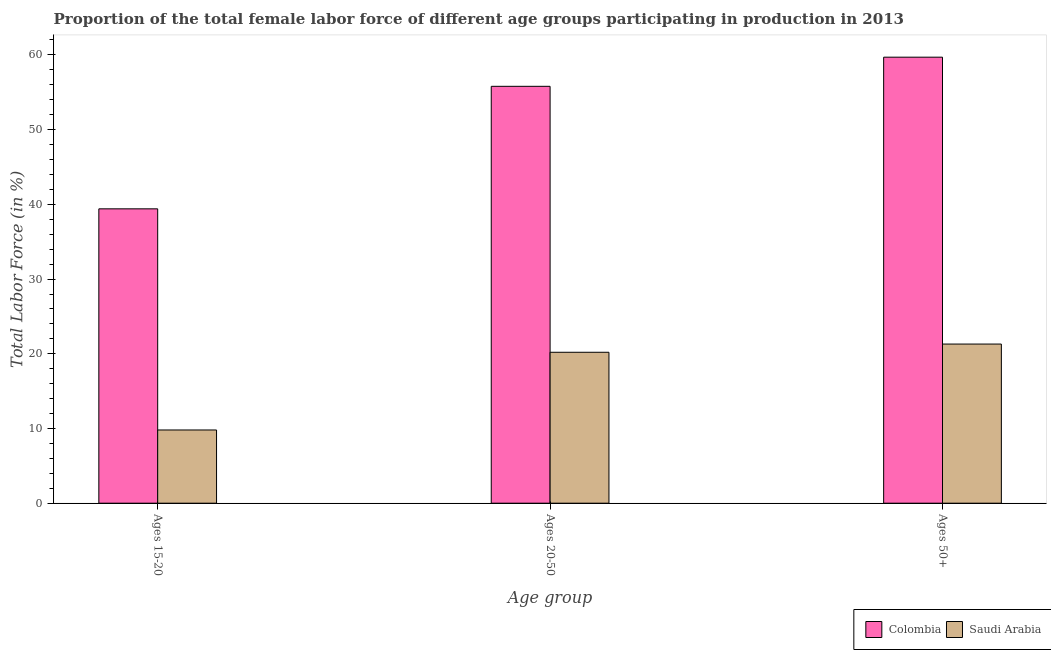How many different coloured bars are there?
Make the answer very short. 2. What is the label of the 3rd group of bars from the left?
Your answer should be very brief. Ages 50+. What is the percentage of female labor force within the age group 20-50 in Saudi Arabia?
Your response must be concise. 20.2. Across all countries, what is the maximum percentage of female labor force above age 50?
Keep it short and to the point. 59.7. Across all countries, what is the minimum percentage of female labor force within the age group 15-20?
Make the answer very short. 9.8. In which country was the percentage of female labor force within the age group 20-50 minimum?
Your response must be concise. Saudi Arabia. What is the difference between the percentage of female labor force within the age group 15-20 in Colombia and that in Saudi Arabia?
Your answer should be very brief. 29.6. What is the difference between the percentage of female labor force within the age group 15-20 in Saudi Arabia and the percentage of female labor force above age 50 in Colombia?
Provide a short and direct response. -49.9. What is the average percentage of female labor force within the age group 15-20 per country?
Your answer should be compact. 24.6. What is the difference between the percentage of female labor force within the age group 20-50 and percentage of female labor force within the age group 15-20 in Colombia?
Your answer should be very brief. 16.4. What is the ratio of the percentage of female labor force within the age group 20-50 in Saudi Arabia to that in Colombia?
Give a very brief answer. 0.36. Is the percentage of female labor force within the age group 20-50 in Saudi Arabia less than that in Colombia?
Provide a short and direct response. Yes. What is the difference between the highest and the second highest percentage of female labor force above age 50?
Offer a very short reply. 38.4. What is the difference between the highest and the lowest percentage of female labor force above age 50?
Provide a succinct answer. 38.4. Is the sum of the percentage of female labor force within the age group 15-20 in Saudi Arabia and Colombia greater than the maximum percentage of female labor force within the age group 20-50 across all countries?
Offer a terse response. No. What does the 1st bar from the left in Ages 15-20 represents?
Provide a succinct answer. Colombia. What does the 1st bar from the right in Ages 20-50 represents?
Provide a succinct answer. Saudi Arabia. How many countries are there in the graph?
Provide a succinct answer. 2. Does the graph contain any zero values?
Keep it short and to the point. No. Does the graph contain grids?
Give a very brief answer. No. Where does the legend appear in the graph?
Give a very brief answer. Bottom right. How are the legend labels stacked?
Offer a terse response. Horizontal. What is the title of the graph?
Keep it short and to the point. Proportion of the total female labor force of different age groups participating in production in 2013. What is the label or title of the X-axis?
Offer a terse response. Age group. What is the label or title of the Y-axis?
Your answer should be compact. Total Labor Force (in %). What is the Total Labor Force (in %) of Colombia in Ages 15-20?
Your response must be concise. 39.4. What is the Total Labor Force (in %) of Saudi Arabia in Ages 15-20?
Your response must be concise. 9.8. What is the Total Labor Force (in %) in Colombia in Ages 20-50?
Provide a succinct answer. 55.8. What is the Total Labor Force (in %) in Saudi Arabia in Ages 20-50?
Provide a short and direct response. 20.2. What is the Total Labor Force (in %) of Colombia in Ages 50+?
Ensure brevity in your answer.  59.7. What is the Total Labor Force (in %) of Saudi Arabia in Ages 50+?
Your answer should be compact. 21.3. Across all Age group, what is the maximum Total Labor Force (in %) of Colombia?
Provide a succinct answer. 59.7. Across all Age group, what is the maximum Total Labor Force (in %) in Saudi Arabia?
Make the answer very short. 21.3. Across all Age group, what is the minimum Total Labor Force (in %) in Colombia?
Offer a terse response. 39.4. Across all Age group, what is the minimum Total Labor Force (in %) of Saudi Arabia?
Offer a terse response. 9.8. What is the total Total Labor Force (in %) in Colombia in the graph?
Make the answer very short. 154.9. What is the total Total Labor Force (in %) in Saudi Arabia in the graph?
Offer a terse response. 51.3. What is the difference between the Total Labor Force (in %) of Colombia in Ages 15-20 and that in Ages 20-50?
Offer a terse response. -16.4. What is the difference between the Total Labor Force (in %) in Saudi Arabia in Ages 15-20 and that in Ages 20-50?
Your answer should be very brief. -10.4. What is the difference between the Total Labor Force (in %) of Colombia in Ages 15-20 and that in Ages 50+?
Provide a short and direct response. -20.3. What is the difference between the Total Labor Force (in %) of Colombia in Ages 15-20 and the Total Labor Force (in %) of Saudi Arabia in Ages 50+?
Your answer should be very brief. 18.1. What is the difference between the Total Labor Force (in %) in Colombia in Ages 20-50 and the Total Labor Force (in %) in Saudi Arabia in Ages 50+?
Make the answer very short. 34.5. What is the average Total Labor Force (in %) of Colombia per Age group?
Your answer should be very brief. 51.63. What is the difference between the Total Labor Force (in %) of Colombia and Total Labor Force (in %) of Saudi Arabia in Ages 15-20?
Ensure brevity in your answer.  29.6. What is the difference between the Total Labor Force (in %) in Colombia and Total Labor Force (in %) in Saudi Arabia in Ages 20-50?
Offer a very short reply. 35.6. What is the difference between the Total Labor Force (in %) of Colombia and Total Labor Force (in %) of Saudi Arabia in Ages 50+?
Your answer should be very brief. 38.4. What is the ratio of the Total Labor Force (in %) of Colombia in Ages 15-20 to that in Ages 20-50?
Your answer should be compact. 0.71. What is the ratio of the Total Labor Force (in %) of Saudi Arabia in Ages 15-20 to that in Ages 20-50?
Your answer should be very brief. 0.49. What is the ratio of the Total Labor Force (in %) of Colombia in Ages 15-20 to that in Ages 50+?
Your answer should be compact. 0.66. What is the ratio of the Total Labor Force (in %) of Saudi Arabia in Ages 15-20 to that in Ages 50+?
Make the answer very short. 0.46. What is the ratio of the Total Labor Force (in %) of Colombia in Ages 20-50 to that in Ages 50+?
Offer a very short reply. 0.93. What is the ratio of the Total Labor Force (in %) of Saudi Arabia in Ages 20-50 to that in Ages 50+?
Give a very brief answer. 0.95. What is the difference between the highest and the second highest Total Labor Force (in %) in Saudi Arabia?
Make the answer very short. 1.1. What is the difference between the highest and the lowest Total Labor Force (in %) in Colombia?
Offer a very short reply. 20.3. 